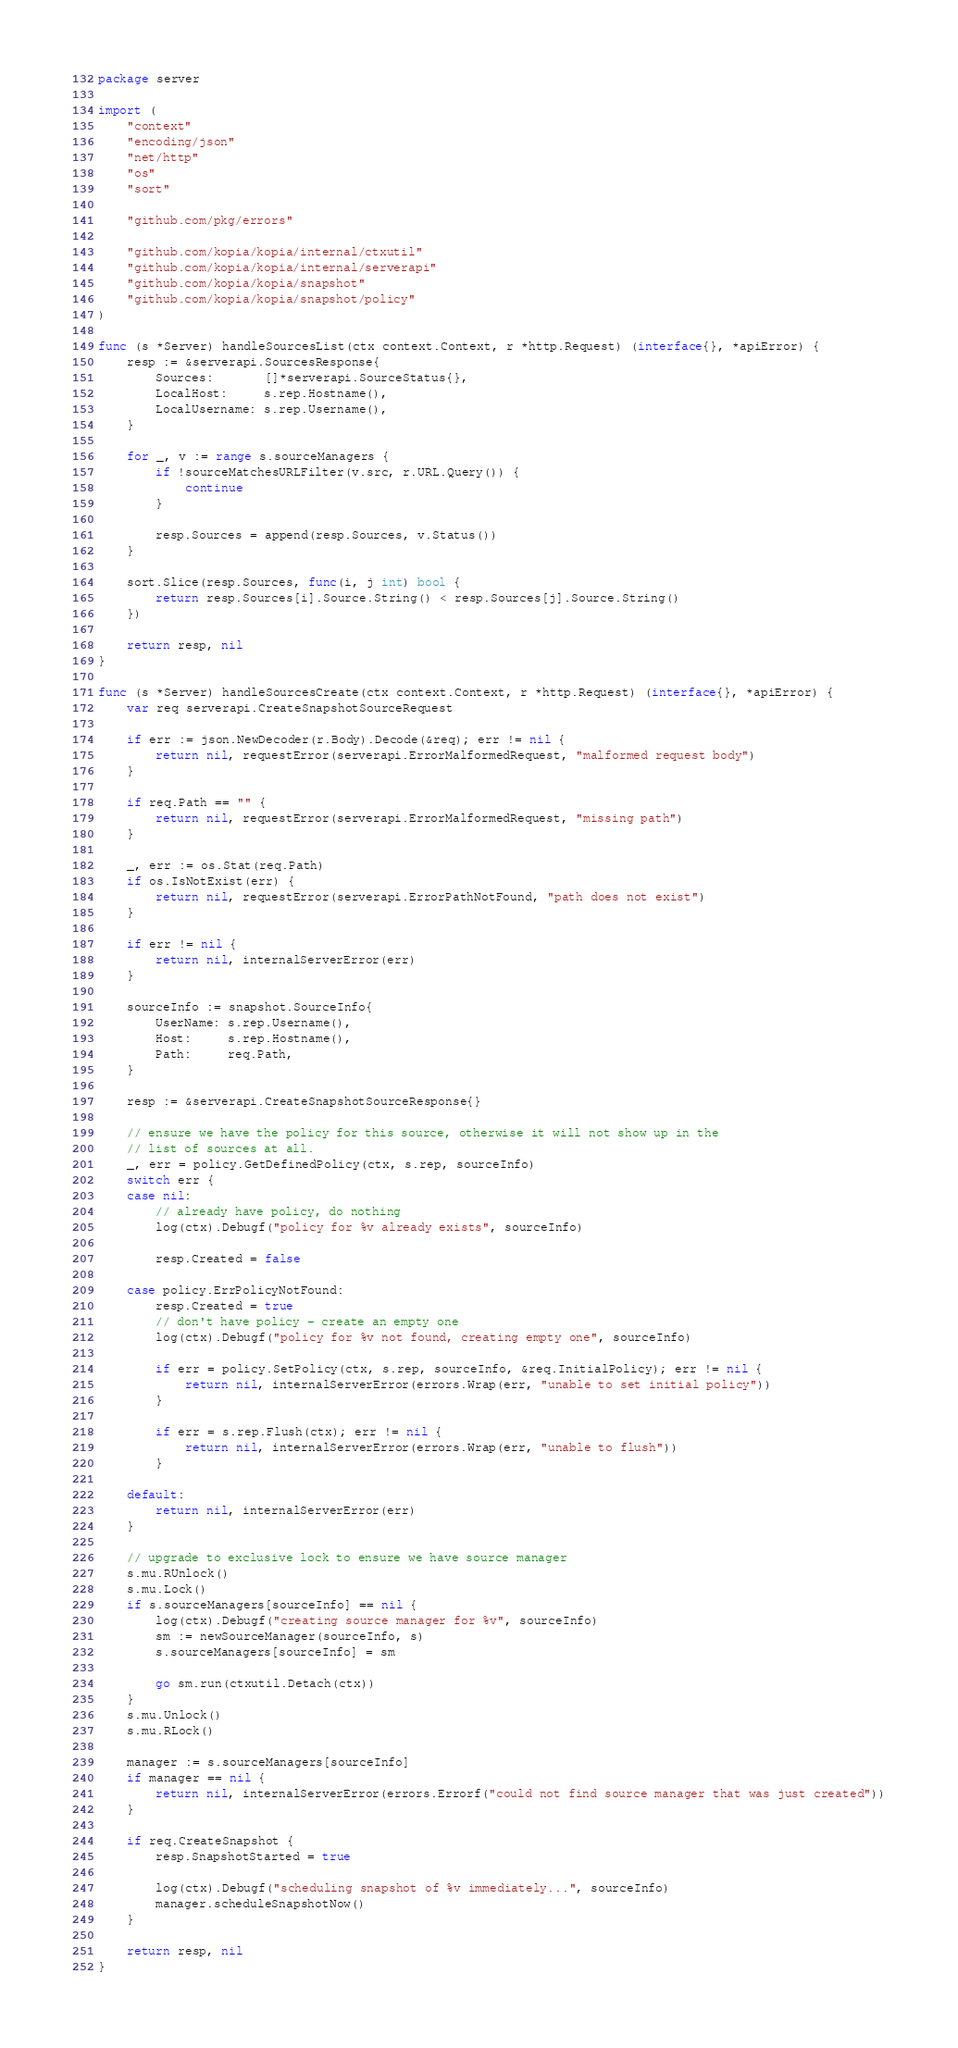<code> <loc_0><loc_0><loc_500><loc_500><_Go_>package server

import (
	"context"
	"encoding/json"
	"net/http"
	"os"
	"sort"

	"github.com/pkg/errors"

	"github.com/kopia/kopia/internal/ctxutil"
	"github.com/kopia/kopia/internal/serverapi"
	"github.com/kopia/kopia/snapshot"
	"github.com/kopia/kopia/snapshot/policy"
)

func (s *Server) handleSourcesList(ctx context.Context, r *http.Request) (interface{}, *apiError) {
	resp := &serverapi.SourcesResponse{
		Sources:       []*serverapi.SourceStatus{},
		LocalHost:     s.rep.Hostname(),
		LocalUsername: s.rep.Username(),
	}

	for _, v := range s.sourceManagers {
		if !sourceMatchesURLFilter(v.src, r.URL.Query()) {
			continue
		}

		resp.Sources = append(resp.Sources, v.Status())
	}

	sort.Slice(resp.Sources, func(i, j int) bool {
		return resp.Sources[i].Source.String() < resp.Sources[j].Source.String()
	})

	return resp, nil
}

func (s *Server) handleSourcesCreate(ctx context.Context, r *http.Request) (interface{}, *apiError) {
	var req serverapi.CreateSnapshotSourceRequest

	if err := json.NewDecoder(r.Body).Decode(&req); err != nil {
		return nil, requestError(serverapi.ErrorMalformedRequest, "malformed request body")
	}

	if req.Path == "" {
		return nil, requestError(serverapi.ErrorMalformedRequest, "missing path")
	}

	_, err := os.Stat(req.Path)
	if os.IsNotExist(err) {
		return nil, requestError(serverapi.ErrorPathNotFound, "path does not exist")
	}

	if err != nil {
		return nil, internalServerError(err)
	}

	sourceInfo := snapshot.SourceInfo{
		UserName: s.rep.Username(),
		Host:     s.rep.Hostname(),
		Path:     req.Path,
	}

	resp := &serverapi.CreateSnapshotSourceResponse{}

	// ensure we have the policy for this source, otherwise it will not show up in the
	// list of sources at all.
	_, err = policy.GetDefinedPolicy(ctx, s.rep, sourceInfo)
	switch err {
	case nil:
		// already have policy, do nothing
		log(ctx).Debugf("policy for %v already exists", sourceInfo)

		resp.Created = false

	case policy.ErrPolicyNotFound:
		resp.Created = true
		// don't have policy - create an empty one
		log(ctx).Debugf("policy for %v not found, creating empty one", sourceInfo)

		if err = policy.SetPolicy(ctx, s.rep, sourceInfo, &req.InitialPolicy); err != nil {
			return nil, internalServerError(errors.Wrap(err, "unable to set initial policy"))
		}

		if err = s.rep.Flush(ctx); err != nil {
			return nil, internalServerError(errors.Wrap(err, "unable to flush"))
		}

	default:
		return nil, internalServerError(err)
	}

	// upgrade to exclusive lock to ensure we have source manager
	s.mu.RUnlock()
	s.mu.Lock()
	if s.sourceManagers[sourceInfo] == nil {
		log(ctx).Debugf("creating source manager for %v", sourceInfo)
		sm := newSourceManager(sourceInfo, s)
		s.sourceManagers[sourceInfo] = sm

		go sm.run(ctxutil.Detach(ctx))
	}
	s.mu.Unlock()
	s.mu.RLock()

	manager := s.sourceManagers[sourceInfo]
	if manager == nil {
		return nil, internalServerError(errors.Errorf("could not find source manager that was just created"))
	}

	if req.CreateSnapshot {
		resp.SnapshotStarted = true

		log(ctx).Debugf("scheduling snapshot of %v immediately...", sourceInfo)
		manager.scheduleSnapshotNow()
	}

	return resp, nil
}
</code> 